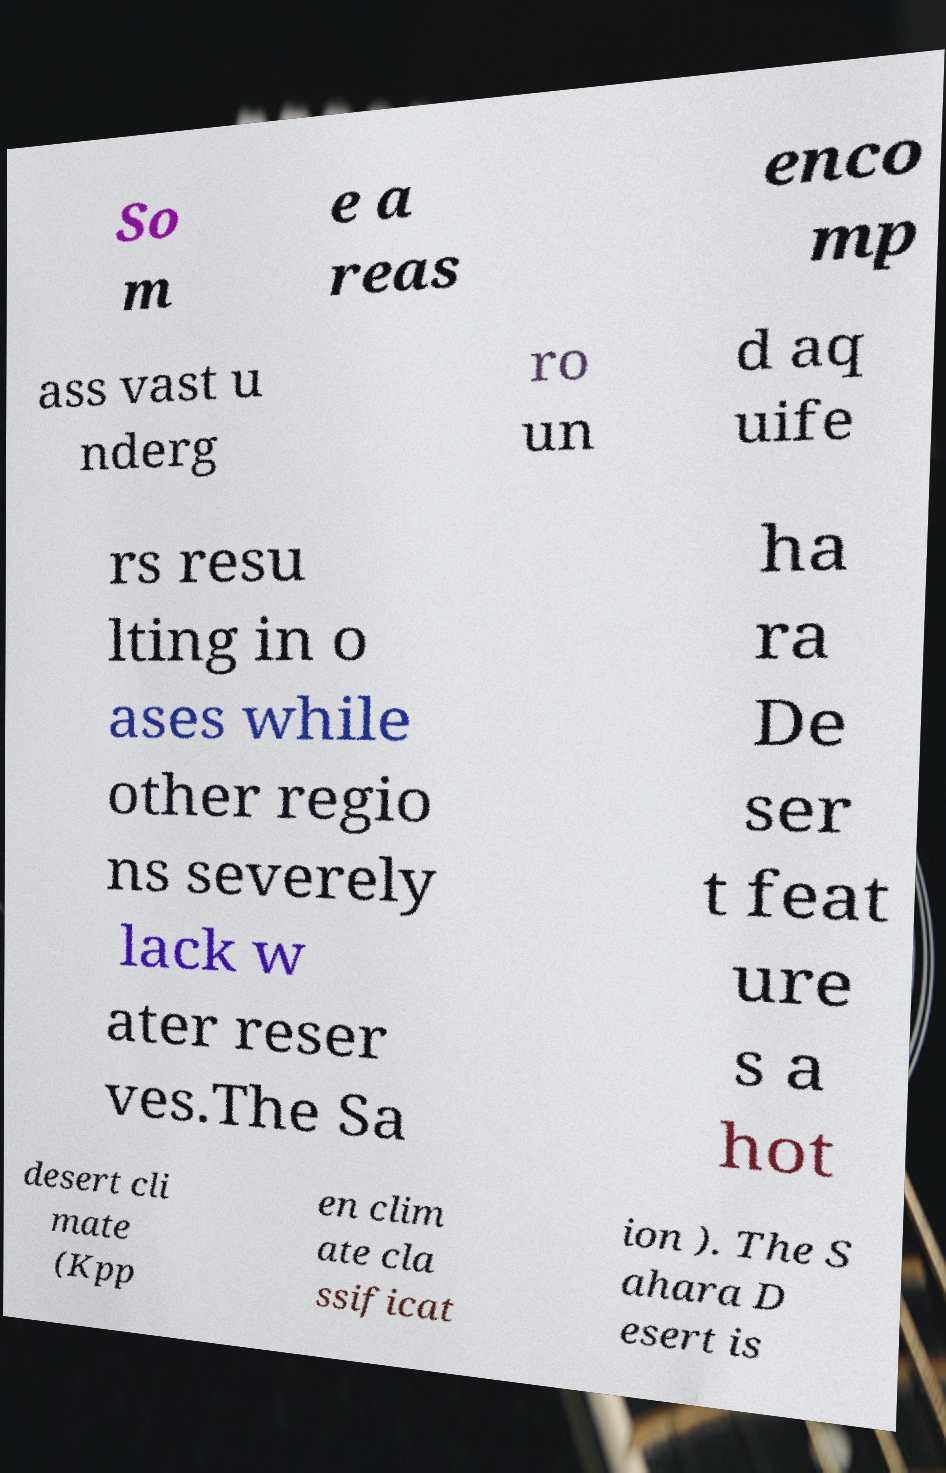For documentation purposes, I need the text within this image transcribed. Could you provide that? So m e a reas enco mp ass vast u nderg ro un d aq uife rs resu lting in o ases while other regio ns severely lack w ater reser ves.The Sa ha ra De ser t feat ure s a hot desert cli mate (Kpp en clim ate cla ssificat ion ). The S ahara D esert is 